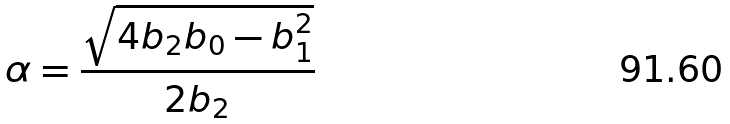Convert formula to latex. <formula><loc_0><loc_0><loc_500><loc_500>\alpha = \frac { \sqrt { 4 b _ { 2 } b _ { 0 } - b _ { 1 } ^ { 2 } } } { 2 b _ { 2 } }</formula> 